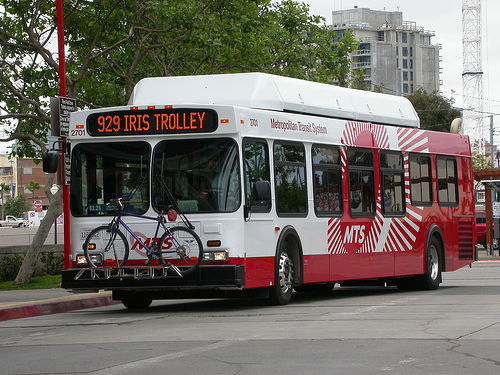Identify the text contained in this image. 929 IRIS TROLLEY 2701 MTS 